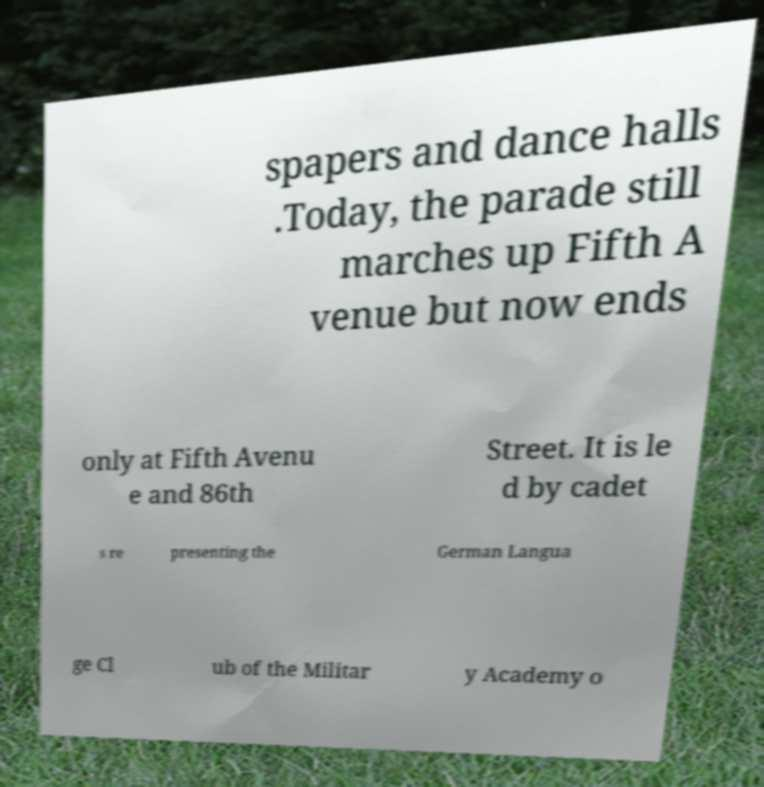Could you assist in decoding the text presented in this image and type it out clearly? spapers and dance halls .Today, the parade still marches up Fifth A venue but now ends only at Fifth Avenu e and 86th Street. It is le d by cadet s re presenting the German Langua ge Cl ub of the Militar y Academy o 